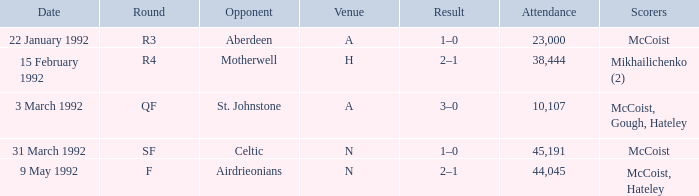What is the result with an attendance larger than 10,107 and Celtic as the opponent? 1–0. 